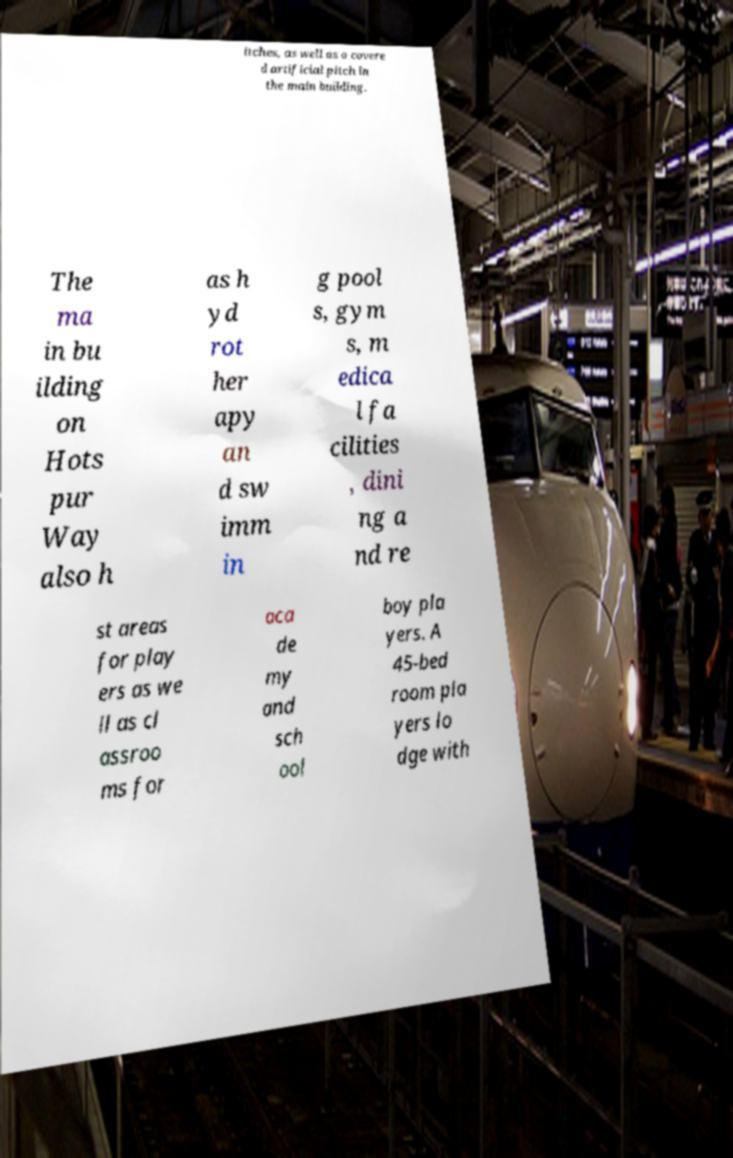Could you assist in decoding the text presented in this image and type it out clearly? itches, as well as a covere d artificial pitch in the main building. The ma in bu ilding on Hots pur Way also h as h yd rot her apy an d sw imm in g pool s, gym s, m edica l fa cilities , dini ng a nd re st areas for play ers as we ll as cl assroo ms for aca de my and sch ool boy pla yers. A 45-bed room pla yers lo dge with 